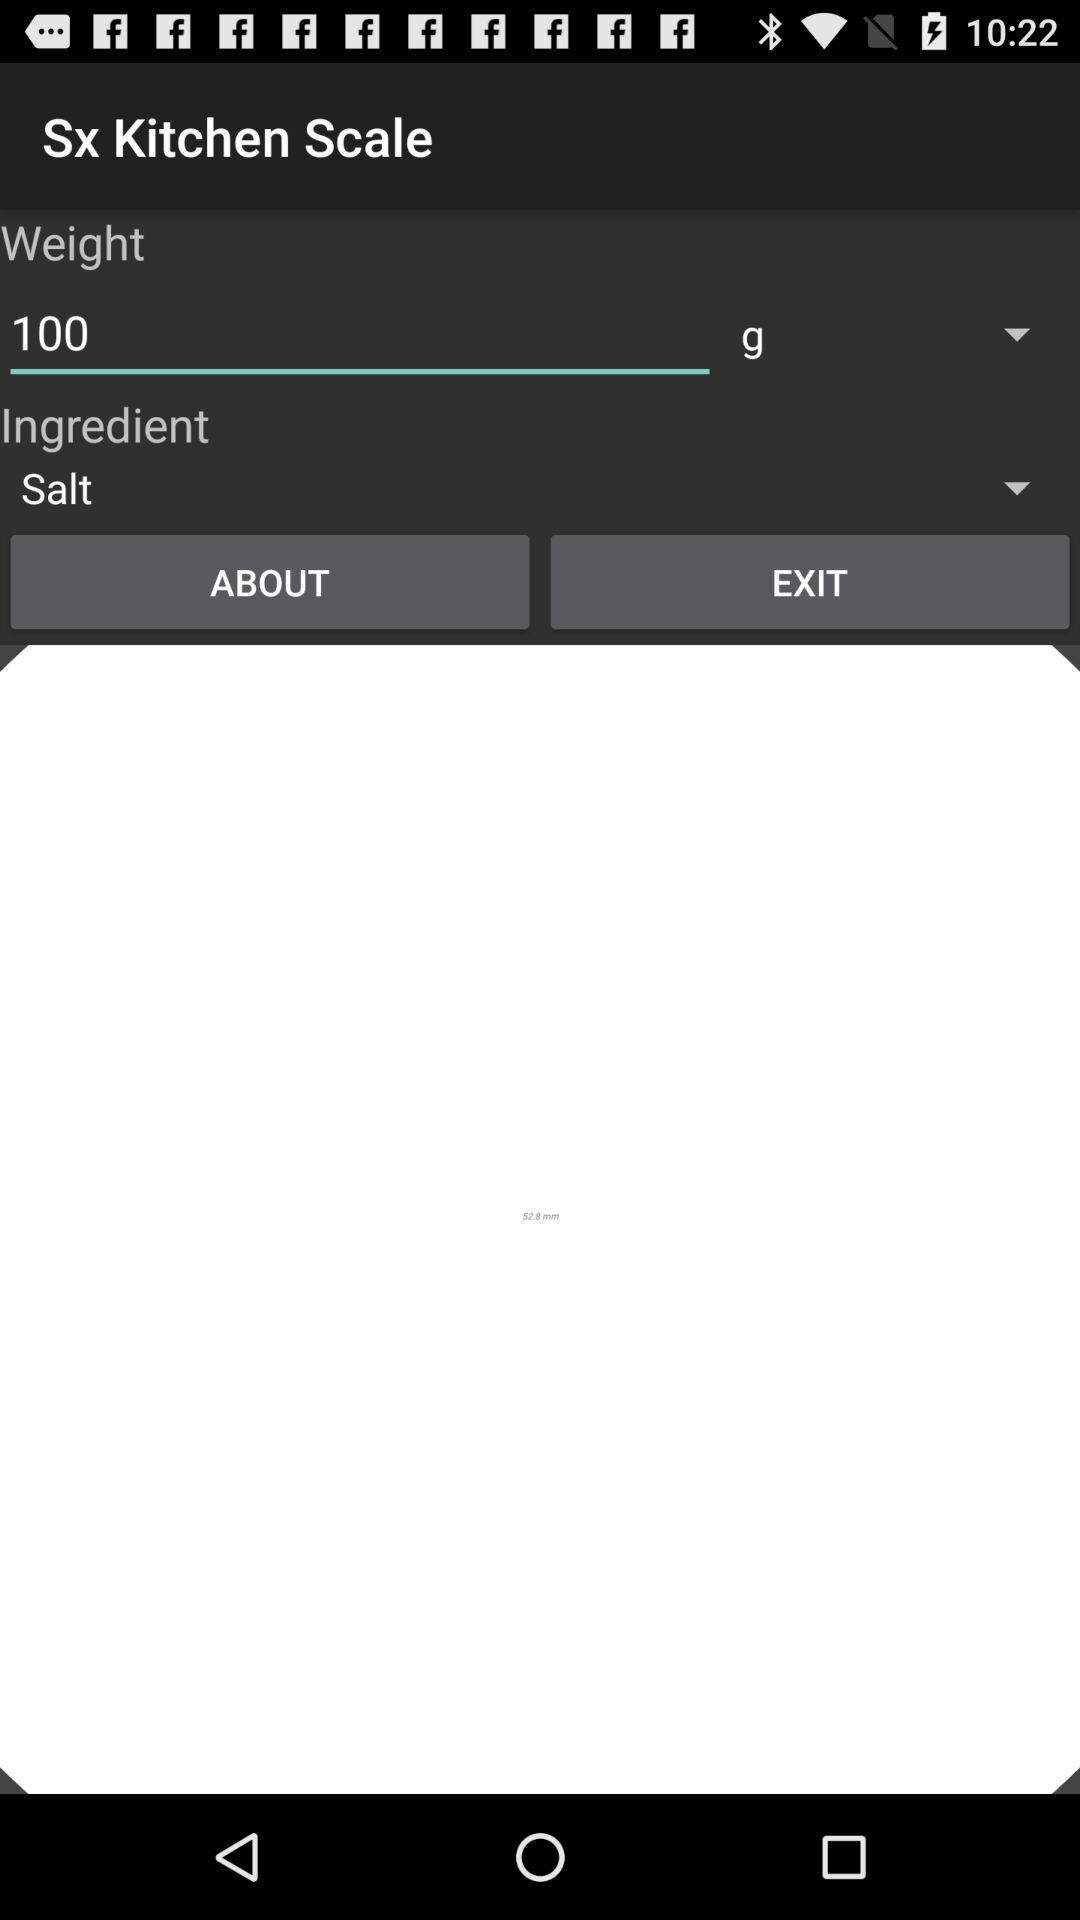What is the selected ingredient name? The selected ingredient name is salt. 